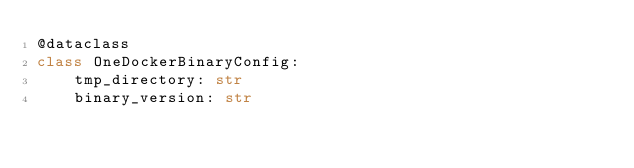<code> <loc_0><loc_0><loc_500><loc_500><_Python_>@dataclass
class OneDockerBinaryConfig:
    tmp_directory: str
    binary_version: str
</code> 